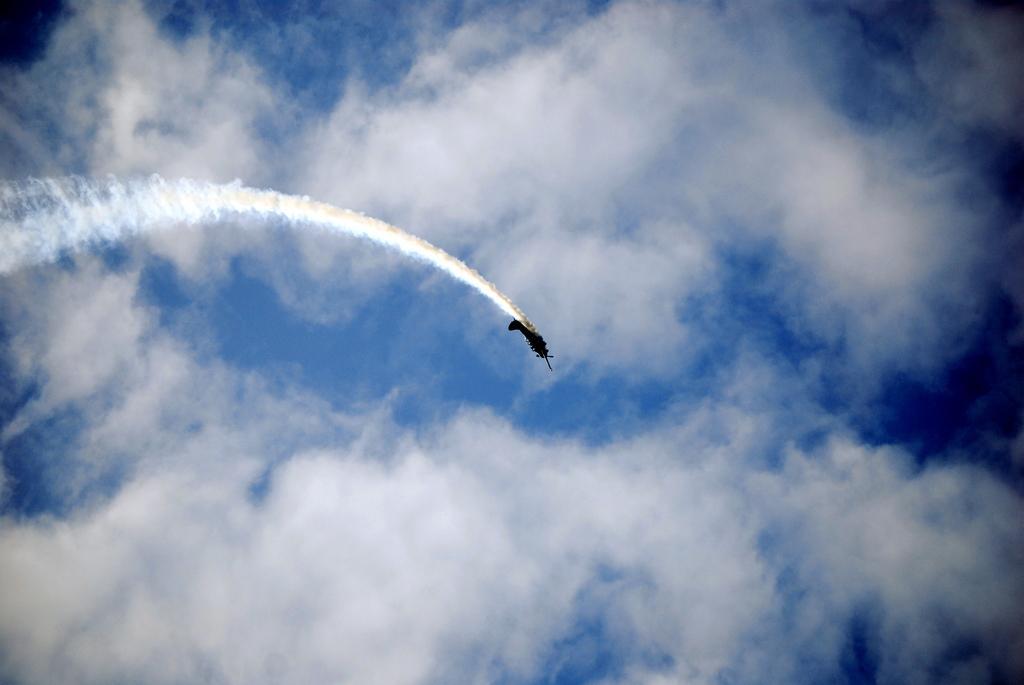Please provide a concise description of this image. In the middle of the image we can see a plane in the air and we can see clouds. 